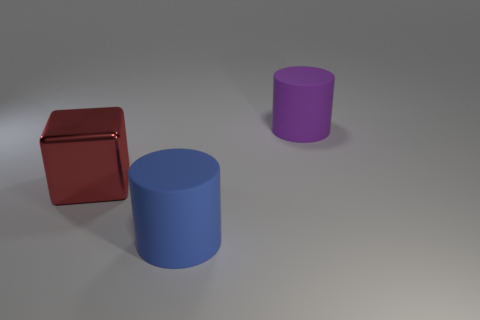Which object is the closest to the light source? Based on the shadows and lighting in the image, the red block seems to be the closest to the light source. How can you tell? The intensity of the shadows and the brightness on the objects give us clues about their proximity to the light source. The red block has the sharpest and darkest shadow, indicating it is closest to the light. 